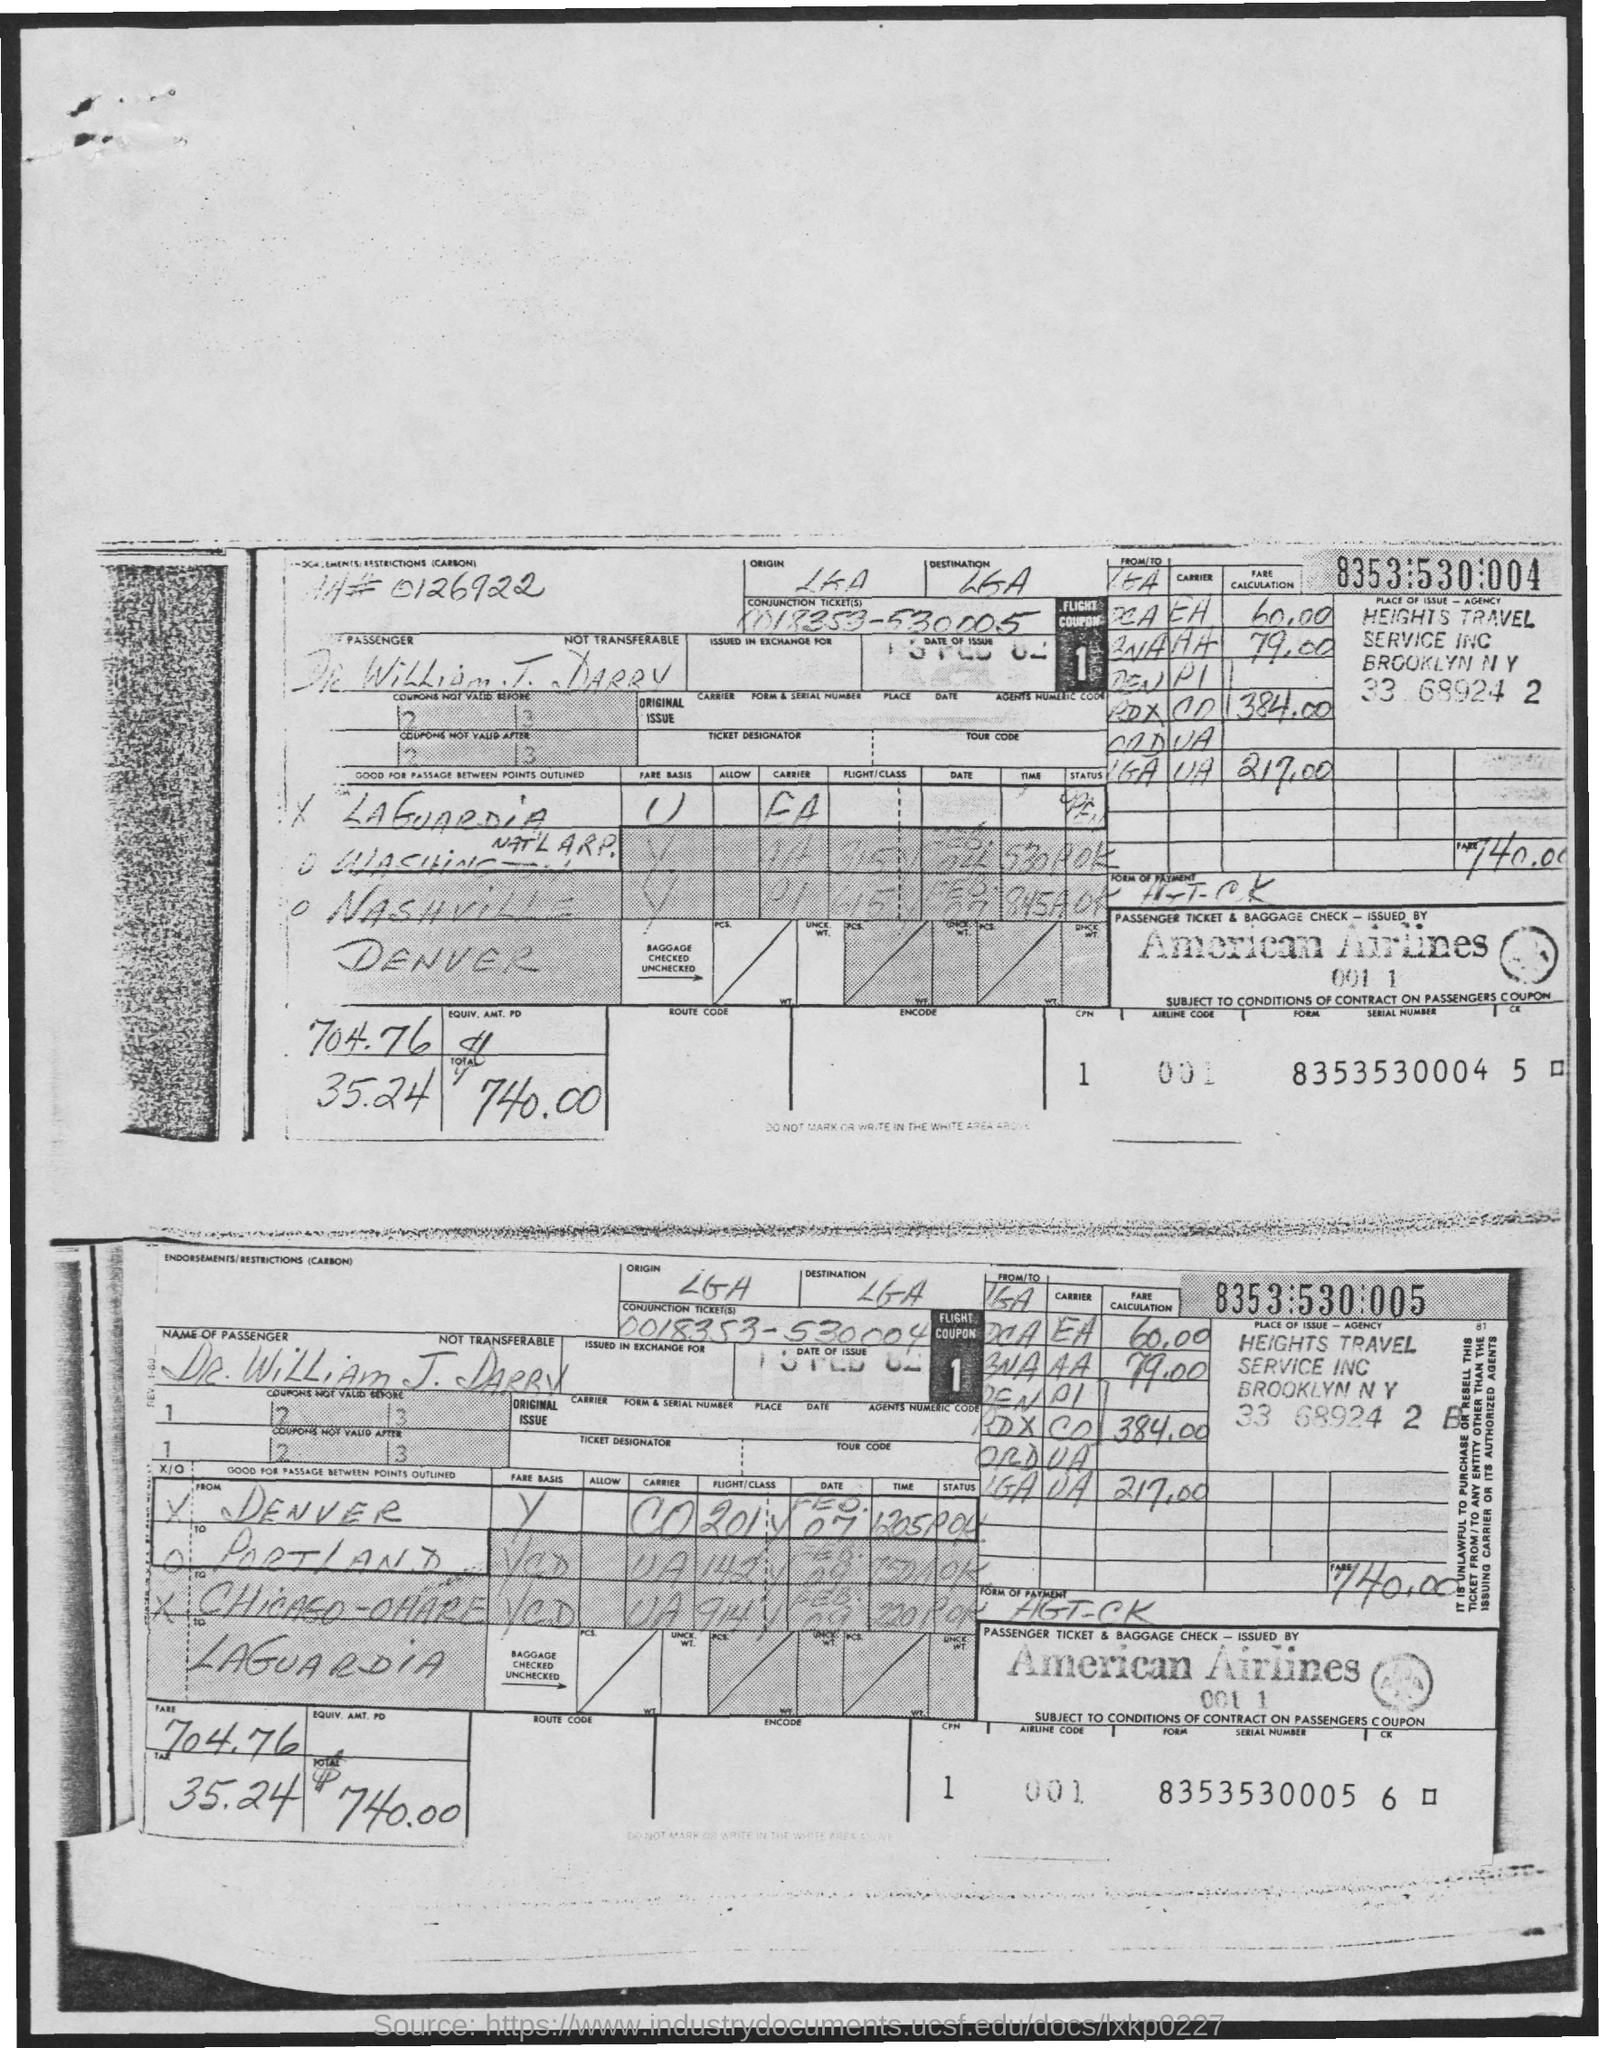Mention a couple of crucial points in this snapshot. The fare is 704.76... The name of the airline is American Airlines. The total is 740.00. The airline code is a unique identifier assigned to airlines by the International Air Transport Association (IATA). The code consists of a four-digit number, with the first digit indicating the airline's membership in the IATA. The tax amount is 35.24. 